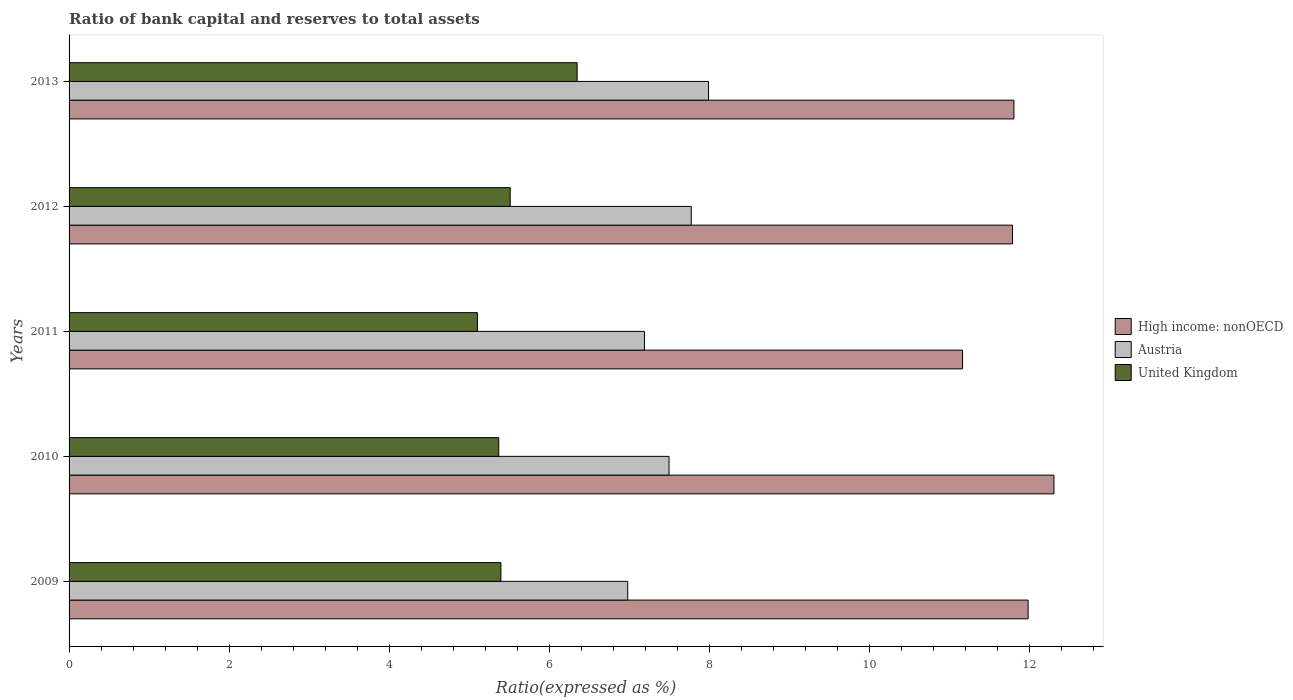How many different coloured bars are there?
Keep it short and to the point. 3. Are the number of bars per tick equal to the number of legend labels?
Offer a terse response. Yes. Are the number of bars on each tick of the Y-axis equal?
Offer a very short reply. Yes. How many bars are there on the 3rd tick from the bottom?
Ensure brevity in your answer.  3. In how many cases, is the number of bars for a given year not equal to the number of legend labels?
Provide a succinct answer. 0. Across all years, what is the maximum ratio of bank capital and reserves to total assets in Austria?
Keep it short and to the point. 7.99. Across all years, what is the minimum ratio of bank capital and reserves to total assets in High income: nonOECD?
Your response must be concise. 11.16. In which year was the ratio of bank capital and reserves to total assets in United Kingdom minimum?
Your response must be concise. 2011. What is the total ratio of bank capital and reserves to total assets in Austria in the graph?
Offer a terse response. 37.41. What is the difference between the ratio of bank capital and reserves to total assets in United Kingdom in 2011 and that in 2013?
Your answer should be compact. -1.25. What is the difference between the ratio of bank capital and reserves to total assets in United Kingdom in 2009 and the ratio of bank capital and reserves to total assets in High income: nonOECD in 2012?
Your response must be concise. -6.39. What is the average ratio of bank capital and reserves to total assets in High income: nonOECD per year?
Ensure brevity in your answer.  11.8. In the year 2012, what is the difference between the ratio of bank capital and reserves to total assets in United Kingdom and ratio of bank capital and reserves to total assets in Austria?
Give a very brief answer. -2.26. In how many years, is the ratio of bank capital and reserves to total assets in Austria greater than 2 %?
Your answer should be compact. 5. What is the ratio of the ratio of bank capital and reserves to total assets in High income: nonOECD in 2011 to that in 2013?
Your response must be concise. 0.95. What is the difference between the highest and the second highest ratio of bank capital and reserves to total assets in United Kingdom?
Ensure brevity in your answer.  0.84. What is the difference between the highest and the lowest ratio of bank capital and reserves to total assets in United Kingdom?
Give a very brief answer. 1.25. In how many years, is the ratio of bank capital and reserves to total assets in United Kingdom greater than the average ratio of bank capital and reserves to total assets in United Kingdom taken over all years?
Ensure brevity in your answer.  1. Is the sum of the ratio of bank capital and reserves to total assets in United Kingdom in 2009 and 2010 greater than the maximum ratio of bank capital and reserves to total assets in Austria across all years?
Give a very brief answer. Yes. What does the 3rd bar from the top in 2013 represents?
Offer a terse response. High income: nonOECD. What does the 1st bar from the bottom in 2010 represents?
Offer a very short reply. High income: nonOECD. Is it the case that in every year, the sum of the ratio of bank capital and reserves to total assets in High income: nonOECD and ratio of bank capital and reserves to total assets in Austria is greater than the ratio of bank capital and reserves to total assets in United Kingdom?
Ensure brevity in your answer.  Yes. What is the difference between two consecutive major ticks on the X-axis?
Give a very brief answer. 2. How many legend labels are there?
Make the answer very short. 3. What is the title of the graph?
Your answer should be compact. Ratio of bank capital and reserves to total assets. What is the label or title of the X-axis?
Give a very brief answer. Ratio(expressed as %). What is the Ratio(expressed as %) of High income: nonOECD in 2009?
Make the answer very short. 11.98. What is the Ratio(expressed as %) in Austria in 2009?
Provide a succinct answer. 6.98. What is the Ratio(expressed as %) of United Kingdom in 2009?
Keep it short and to the point. 5.39. What is the Ratio(expressed as %) in High income: nonOECD in 2010?
Your answer should be very brief. 12.3. What is the Ratio(expressed as %) in Austria in 2010?
Provide a succinct answer. 7.49. What is the Ratio(expressed as %) of United Kingdom in 2010?
Give a very brief answer. 5.37. What is the Ratio(expressed as %) of High income: nonOECD in 2011?
Make the answer very short. 11.16. What is the Ratio(expressed as %) in Austria in 2011?
Offer a very short reply. 7.19. What is the Ratio(expressed as %) of United Kingdom in 2011?
Your answer should be compact. 5.1. What is the Ratio(expressed as %) in High income: nonOECD in 2012?
Offer a very short reply. 11.78. What is the Ratio(expressed as %) of Austria in 2012?
Ensure brevity in your answer.  7.77. What is the Ratio(expressed as %) in United Kingdom in 2012?
Keep it short and to the point. 5.51. What is the Ratio(expressed as %) of High income: nonOECD in 2013?
Ensure brevity in your answer.  11.8. What is the Ratio(expressed as %) in Austria in 2013?
Make the answer very short. 7.99. What is the Ratio(expressed as %) in United Kingdom in 2013?
Offer a terse response. 6.35. Across all years, what is the maximum Ratio(expressed as %) in Austria?
Provide a short and direct response. 7.99. Across all years, what is the maximum Ratio(expressed as %) of United Kingdom?
Offer a very short reply. 6.35. Across all years, what is the minimum Ratio(expressed as %) of High income: nonOECD?
Your answer should be compact. 11.16. Across all years, what is the minimum Ratio(expressed as %) in Austria?
Ensure brevity in your answer.  6.98. Across all years, what is the minimum Ratio(expressed as %) in United Kingdom?
Your answer should be compact. 5.1. What is the total Ratio(expressed as %) of High income: nonOECD in the graph?
Offer a very short reply. 59.02. What is the total Ratio(expressed as %) in Austria in the graph?
Your answer should be compact. 37.41. What is the total Ratio(expressed as %) in United Kingdom in the graph?
Give a very brief answer. 27.71. What is the difference between the Ratio(expressed as %) in High income: nonOECD in 2009 and that in 2010?
Make the answer very short. -0.32. What is the difference between the Ratio(expressed as %) in Austria in 2009 and that in 2010?
Your answer should be compact. -0.52. What is the difference between the Ratio(expressed as %) in United Kingdom in 2009 and that in 2010?
Provide a short and direct response. 0.03. What is the difference between the Ratio(expressed as %) of High income: nonOECD in 2009 and that in 2011?
Your answer should be compact. 0.82. What is the difference between the Ratio(expressed as %) of Austria in 2009 and that in 2011?
Your answer should be very brief. -0.21. What is the difference between the Ratio(expressed as %) of United Kingdom in 2009 and that in 2011?
Offer a terse response. 0.29. What is the difference between the Ratio(expressed as %) of High income: nonOECD in 2009 and that in 2012?
Give a very brief answer. 0.2. What is the difference between the Ratio(expressed as %) of Austria in 2009 and that in 2012?
Your answer should be very brief. -0.79. What is the difference between the Ratio(expressed as %) of United Kingdom in 2009 and that in 2012?
Your answer should be compact. -0.12. What is the difference between the Ratio(expressed as %) in High income: nonOECD in 2009 and that in 2013?
Your answer should be compact. 0.18. What is the difference between the Ratio(expressed as %) in Austria in 2009 and that in 2013?
Offer a terse response. -1.01. What is the difference between the Ratio(expressed as %) of United Kingdom in 2009 and that in 2013?
Provide a short and direct response. -0.95. What is the difference between the Ratio(expressed as %) in High income: nonOECD in 2010 and that in 2011?
Your response must be concise. 1.14. What is the difference between the Ratio(expressed as %) in Austria in 2010 and that in 2011?
Your answer should be compact. 0.31. What is the difference between the Ratio(expressed as %) of United Kingdom in 2010 and that in 2011?
Your answer should be compact. 0.27. What is the difference between the Ratio(expressed as %) of High income: nonOECD in 2010 and that in 2012?
Offer a terse response. 0.52. What is the difference between the Ratio(expressed as %) in Austria in 2010 and that in 2012?
Your answer should be compact. -0.28. What is the difference between the Ratio(expressed as %) of United Kingdom in 2010 and that in 2012?
Your answer should be very brief. -0.14. What is the difference between the Ratio(expressed as %) of High income: nonOECD in 2010 and that in 2013?
Keep it short and to the point. 0.5. What is the difference between the Ratio(expressed as %) in Austria in 2010 and that in 2013?
Provide a short and direct response. -0.49. What is the difference between the Ratio(expressed as %) in United Kingdom in 2010 and that in 2013?
Make the answer very short. -0.98. What is the difference between the Ratio(expressed as %) of High income: nonOECD in 2011 and that in 2012?
Your response must be concise. -0.62. What is the difference between the Ratio(expressed as %) of Austria in 2011 and that in 2012?
Offer a very short reply. -0.58. What is the difference between the Ratio(expressed as %) in United Kingdom in 2011 and that in 2012?
Ensure brevity in your answer.  -0.41. What is the difference between the Ratio(expressed as %) in High income: nonOECD in 2011 and that in 2013?
Your answer should be compact. -0.64. What is the difference between the Ratio(expressed as %) of Austria in 2011 and that in 2013?
Your answer should be compact. -0.8. What is the difference between the Ratio(expressed as %) of United Kingdom in 2011 and that in 2013?
Give a very brief answer. -1.25. What is the difference between the Ratio(expressed as %) in High income: nonOECD in 2012 and that in 2013?
Provide a succinct answer. -0.02. What is the difference between the Ratio(expressed as %) in Austria in 2012 and that in 2013?
Offer a terse response. -0.22. What is the difference between the Ratio(expressed as %) of United Kingdom in 2012 and that in 2013?
Give a very brief answer. -0.84. What is the difference between the Ratio(expressed as %) of High income: nonOECD in 2009 and the Ratio(expressed as %) of Austria in 2010?
Keep it short and to the point. 4.48. What is the difference between the Ratio(expressed as %) in High income: nonOECD in 2009 and the Ratio(expressed as %) in United Kingdom in 2010?
Your answer should be compact. 6.61. What is the difference between the Ratio(expressed as %) in Austria in 2009 and the Ratio(expressed as %) in United Kingdom in 2010?
Offer a terse response. 1.61. What is the difference between the Ratio(expressed as %) in High income: nonOECD in 2009 and the Ratio(expressed as %) in Austria in 2011?
Your answer should be very brief. 4.79. What is the difference between the Ratio(expressed as %) in High income: nonOECD in 2009 and the Ratio(expressed as %) in United Kingdom in 2011?
Provide a succinct answer. 6.88. What is the difference between the Ratio(expressed as %) of Austria in 2009 and the Ratio(expressed as %) of United Kingdom in 2011?
Provide a short and direct response. 1.88. What is the difference between the Ratio(expressed as %) of High income: nonOECD in 2009 and the Ratio(expressed as %) of Austria in 2012?
Make the answer very short. 4.21. What is the difference between the Ratio(expressed as %) in High income: nonOECD in 2009 and the Ratio(expressed as %) in United Kingdom in 2012?
Provide a succinct answer. 6.47. What is the difference between the Ratio(expressed as %) of Austria in 2009 and the Ratio(expressed as %) of United Kingdom in 2012?
Make the answer very short. 1.47. What is the difference between the Ratio(expressed as %) of High income: nonOECD in 2009 and the Ratio(expressed as %) of Austria in 2013?
Provide a short and direct response. 3.99. What is the difference between the Ratio(expressed as %) of High income: nonOECD in 2009 and the Ratio(expressed as %) of United Kingdom in 2013?
Provide a succinct answer. 5.63. What is the difference between the Ratio(expressed as %) of Austria in 2009 and the Ratio(expressed as %) of United Kingdom in 2013?
Your response must be concise. 0.63. What is the difference between the Ratio(expressed as %) in High income: nonOECD in 2010 and the Ratio(expressed as %) in Austria in 2011?
Offer a very short reply. 5.11. What is the difference between the Ratio(expressed as %) in High income: nonOECD in 2010 and the Ratio(expressed as %) in United Kingdom in 2011?
Your answer should be compact. 7.2. What is the difference between the Ratio(expressed as %) in Austria in 2010 and the Ratio(expressed as %) in United Kingdom in 2011?
Provide a succinct answer. 2.39. What is the difference between the Ratio(expressed as %) of High income: nonOECD in 2010 and the Ratio(expressed as %) of Austria in 2012?
Your response must be concise. 4.53. What is the difference between the Ratio(expressed as %) of High income: nonOECD in 2010 and the Ratio(expressed as %) of United Kingdom in 2012?
Provide a short and direct response. 6.79. What is the difference between the Ratio(expressed as %) of Austria in 2010 and the Ratio(expressed as %) of United Kingdom in 2012?
Your response must be concise. 1.98. What is the difference between the Ratio(expressed as %) in High income: nonOECD in 2010 and the Ratio(expressed as %) in Austria in 2013?
Your answer should be very brief. 4.31. What is the difference between the Ratio(expressed as %) in High income: nonOECD in 2010 and the Ratio(expressed as %) in United Kingdom in 2013?
Your answer should be compact. 5.95. What is the difference between the Ratio(expressed as %) of Austria in 2010 and the Ratio(expressed as %) of United Kingdom in 2013?
Make the answer very short. 1.15. What is the difference between the Ratio(expressed as %) of High income: nonOECD in 2011 and the Ratio(expressed as %) of Austria in 2012?
Provide a succinct answer. 3.39. What is the difference between the Ratio(expressed as %) in High income: nonOECD in 2011 and the Ratio(expressed as %) in United Kingdom in 2012?
Provide a short and direct response. 5.65. What is the difference between the Ratio(expressed as %) of Austria in 2011 and the Ratio(expressed as %) of United Kingdom in 2012?
Make the answer very short. 1.68. What is the difference between the Ratio(expressed as %) in High income: nonOECD in 2011 and the Ratio(expressed as %) in Austria in 2013?
Offer a very short reply. 3.17. What is the difference between the Ratio(expressed as %) in High income: nonOECD in 2011 and the Ratio(expressed as %) in United Kingdom in 2013?
Your answer should be compact. 4.81. What is the difference between the Ratio(expressed as %) of Austria in 2011 and the Ratio(expressed as %) of United Kingdom in 2013?
Provide a succinct answer. 0.84. What is the difference between the Ratio(expressed as %) in High income: nonOECD in 2012 and the Ratio(expressed as %) in Austria in 2013?
Your answer should be compact. 3.8. What is the difference between the Ratio(expressed as %) in High income: nonOECD in 2012 and the Ratio(expressed as %) in United Kingdom in 2013?
Offer a terse response. 5.44. What is the difference between the Ratio(expressed as %) of Austria in 2012 and the Ratio(expressed as %) of United Kingdom in 2013?
Make the answer very short. 1.42. What is the average Ratio(expressed as %) of High income: nonOECD per year?
Your response must be concise. 11.8. What is the average Ratio(expressed as %) of Austria per year?
Offer a very short reply. 7.48. What is the average Ratio(expressed as %) of United Kingdom per year?
Make the answer very short. 5.54. In the year 2009, what is the difference between the Ratio(expressed as %) of High income: nonOECD and Ratio(expressed as %) of Austria?
Offer a very short reply. 5. In the year 2009, what is the difference between the Ratio(expressed as %) in High income: nonOECD and Ratio(expressed as %) in United Kingdom?
Offer a very short reply. 6.58. In the year 2009, what is the difference between the Ratio(expressed as %) of Austria and Ratio(expressed as %) of United Kingdom?
Your answer should be very brief. 1.58. In the year 2010, what is the difference between the Ratio(expressed as %) in High income: nonOECD and Ratio(expressed as %) in Austria?
Your answer should be very brief. 4.81. In the year 2010, what is the difference between the Ratio(expressed as %) of High income: nonOECD and Ratio(expressed as %) of United Kingdom?
Give a very brief answer. 6.93. In the year 2010, what is the difference between the Ratio(expressed as %) in Austria and Ratio(expressed as %) in United Kingdom?
Ensure brevity in your answer.  2.13. In the year 2011, what is the difference between the Ratio(expressed as %) of High income: nonOECD and Ratio(expressed as %) of Austria?
Ensure brevity in your answer.  3.97. In the year 2011, what is the difference between the Ratio(expressed as %) of High income: nonOECD and Ratio(expressed as %) of United Kingdom?
Give a very brief answer. 6.06. In the year 2011, what is the difference between the Ratio(expressed as %) of Austria and Ratio(expressed as %) of United Kingdom?
Your response must be concise. 2.09. In the year 2012, what is the difference between the Ratio(expressed as %) in High income: nonOECD and Ratio(expressed as %) in Austria?
Make the answer very short. 4.01. In the year 2012, what is the difference between the Ratio(expressed as %) in High income: nonOECD and Ratio(expressed as %) in United Kingdom?
Your answer should be compact. 6.27. In the year 2012, what is the difference between the Ratio(expressed as %) in Austria and Ratio(expressed as %) in United Kingdom?
Offer a very short reply. 2.26. In the year 2013, what is the difference between the Ratio(expressed as %) in High income: nonOECD and Ratio(expressed as %) in Austria?
Your answer should be compact. 3.81. In the year 2013, what is the difference between the Ratio(expressed as %) of High income: nonOECD and Ratio(expressed as %) of United Kingdom?
Make the answer very short. 5.45. In the year 2013, what is the difference between the Ratio(expressed as %) of Austria and Ratio(expressed as %) of United Kingdom?
Keep it short and to the point. 1.64. What is the ratio of the Ratio(expressed as %) of High income: nonOECD in 2009 to that in 2010?
Your answer should be very brief. 0.97. What is the ratio of the Ratio(expressed as %) of Austria in 2009 to that in 2010?
Ensure brevity in your answer.  0.93. What is the ratio of the Ratio(expressed as %) in High income: nonOECD in 2009 to that in 2011?
Make the answer very short. 1.07. What is the ratio of the Ratio(expressed as %) of Austria in 2009 to that in 2011?
Provide a succinct answer. 0.97. What is the ratio of the Ratio(expressed as %) in United Kingdom in 2009 to that in 2011?
Offer a terse response. 1.06. What is the ratio of the Ratio(expressed as %) in High income: nonOECD in 2009 to that in 2012?
Provide a succinct answer. 1.02. What is the ratio of the Ratio(expressed as %) of Austria in 2009 to that in 2012?
Your answer should be compact. 0.9. What is the ratio of the Ratio(expressed as %) in High income: nonOECD in 2009 to that in 2013?
Keep it short and to the point. 1.01. What is the ratio of the Ratio(expressed as %) of Austria in 2009 to that in 2013?
Your answer should be very brief. 0.87. What is the ratio of the Ratio(expressed as %) in United Kingdom in 2009 to that in 2013?
Provide a succinct answer. 0.85. What is the ratio of the Ratio(expressed as %) of High income: nonOECD in 2010 to that in 2011?
Ensure brevity in your answer.  1.1. What is the ratio of the Ratio(expressed as %) in Austria in 2010 to that in 2011?
Your response must be concise. 1.04. What is the ratio of the Ratio(expressed as %) of United Kingdom in 2010 to that in 2011?
Your answer should be compact. 1.05. What is the ratio of the Ratio(expressed as %) in High income: nonOECD in 2010 to that in 2012?
Provide a succinct answer. 1.04. What is the ratio of the Ratio(expressed as %) in United Kingdom in 2010 to that in 2012?
Your answer should be compact. 0.97. What is the ratio of the Ratio(expressed as %) in High income: nonOECD in 2010 to that in 2013?
Your response must be concise. 1.04. What is the ratio of the Ratio(expressed as %) of Austria in 2010 to that in 2013?
Your answer should be compact. 0.94. What is the ratio of the Ratio(expressed as %) in United Kingdom in 2010 to that in 2013?
Provide a succinct answer. 0.85. What is the ratio of the Ratio(expressed as %) of High income: nonOECD in 2011 to that in 2012?
Provide a succinct answer. 0.95. What is the ratio of the Ratio(expressed as %) of Austria in 2011 to that in 2012?
Your answer should be compact. 0.92. What is the ratio of the Ratio(expressed as %) in United Kingdom in 2011 to that in 2012?
Make the answer very short. 0.93. What is the ratio of the Ratio(expressed as %) in High income: nonOECD in 2011 to that in 2013?
Offer a very short reply. 0.95. What is the ratio of the Ratio(expressed as %) in Austria in 2011 to that in 2013?
Make the answer very short. 0.9. What is the ratio of the Ratio(expressed as %) in United Kingdom in 2011 to that in 2013?
Keep it short and to the point. 0.8. What is the ratio of the Ratio(expressed as %) in High income: nonOECD in 2012 to that in 2013?
Provide a succinct answer. 1. What is the ratio of the Ratio(expressed as %) in Austria in 2012 to that in 2013?
Your answer should be very brief. 0.97. What is the ratio of the Ratio(expressed as %) of United Kingdom in 2012 to that in 2013?
Your response must be concise. 0.87. What is the difference between the highest and the second highest Ratio(expressed as %) of High income: nonOECD?
Give a very brief answer. 0.32. What is the difference between the highest and the second highest Ratio(expressed as %) of Austria?
Provide a short and direct response. 0.22. What is the difference between the highest and the second highest Ratio(expressed as %) of United Kingdom?
Offer a very short reply. 0.84. What is the difference between the highest and the lowest Ratio(expressed as %) of High income: nonOECD?
Give a very brief answer. 1.14. What is the difference between the highest and the lowest Ratio(expressed as %) of Austria?
Offer a terse response. 1.01. What is the difference between the highest and the lowest Ratio(expressed as %) of United Kingdom?
Offer a very short reply. 1.25. 